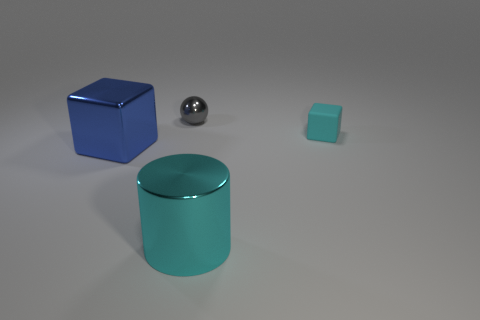Add 3 tiny red matte things. How many objects exist? 7 Subtract all balls. How many objects are left? 3 Subtract all small green rubber things. Subtract all cyan matte blocks. How many objects are left? 3 Add 3 gray objects. How many gray objects are left? 4 Add 2 tiny rubber things. How many tiny rubber things exist? 3 Subtract 0 green balls. How many objects are left? 4 